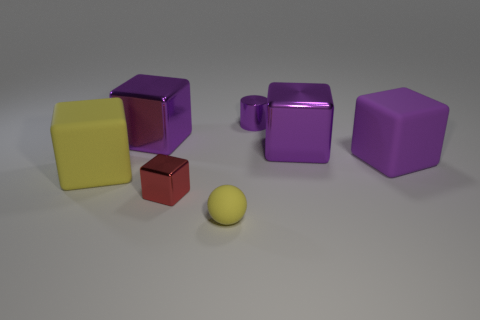Subtract all purple blocks. How many were subtracted if there are1purple blocks left? 2 Subtract all cyan balls. How many purple blocks are left? 3 Subtract all yellow blocks. How many blocks are left? 4 Subtract all red metal cubes. How many cubes are left? 4 Add 1 purple metal cylinders. How many objects exist? 8 Subtract all green blocks. Subtract all brown spheres. How many blocks are left? 5 Subtract all cylinders. How many objects are left? 6 Subtract all gray metallic spheres. Subtract all tiny metallic cubes. How many objects are left? 6 Add 7 yellow objects. How many yellow objects are left? 9 Add 3 rubber things. How many rubber things exist? 6 